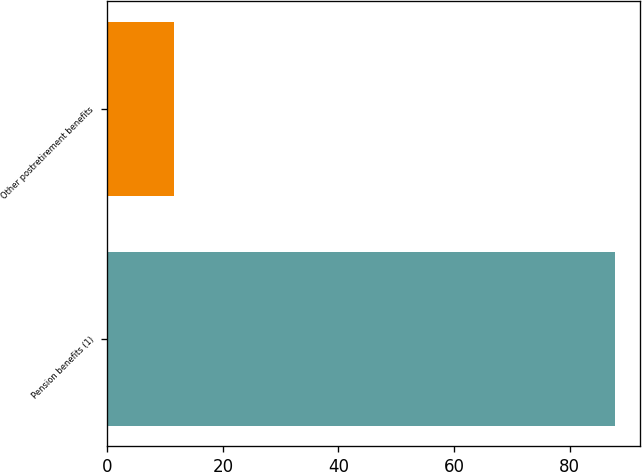Convert chart. <chart><loc_0><loc_0><loc_500><loc_500><bar_chart><fcel>Pension benefits (1)<fcel>Other postretirement benefits<nl><fcel>87.8<fcel>11.5<nl></chart> 